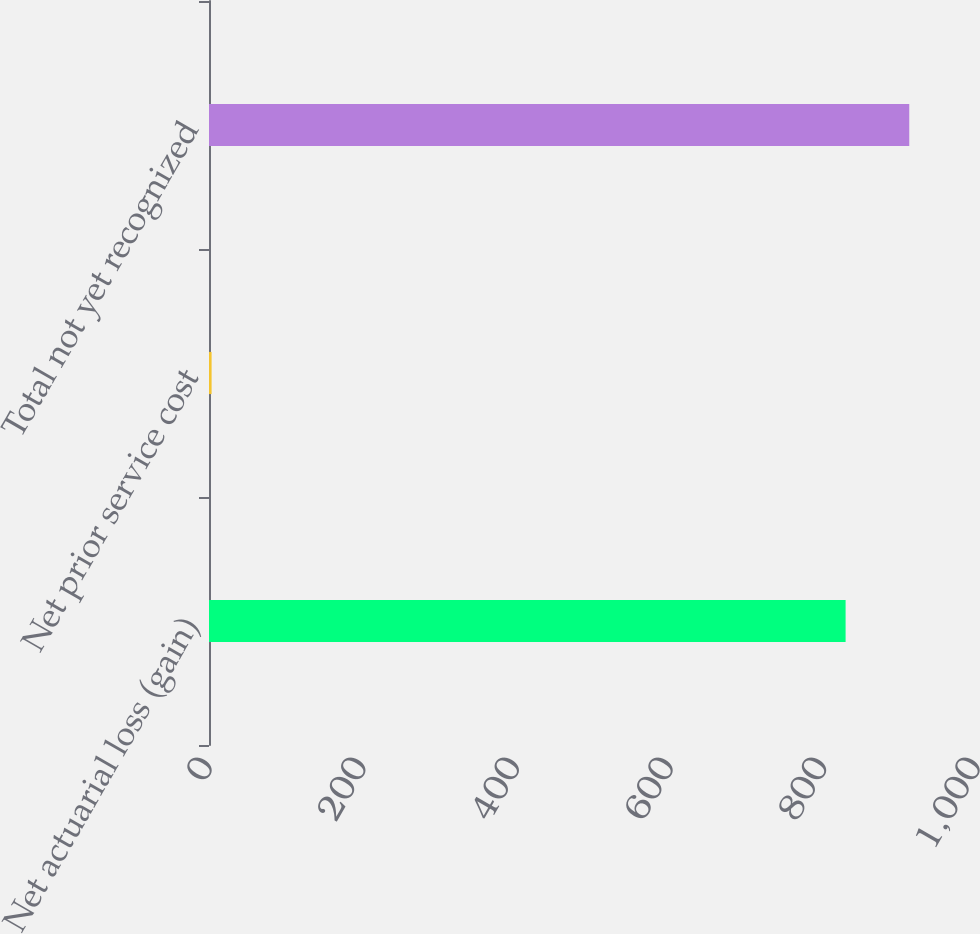Convert chart to OTSL. <chart><loc_0><loc_0><loc_500><loc_500><bar_chart><fcel>Net actuarial loss (gain)<fcel>Net prior service cost<fcel>Total not yet recognized<nl><fcel>828.9<fcel>3.4<fcel>911.79<nl></chart> 